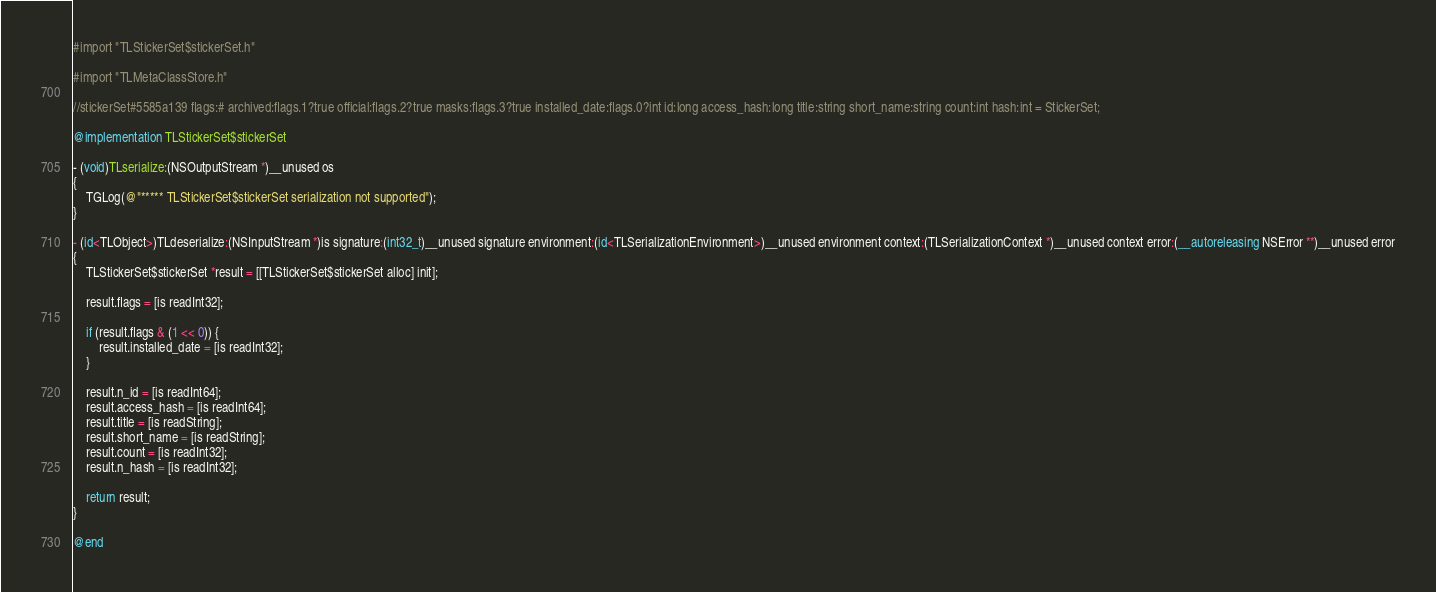<code> <loc_0><loc_0><loc_500><loc_500><_ObjectiveC_>#import "TLStickerSet$stickerSet.h"

#import "TLMetaClassStore.h"

//stickerSet#5585a139 flags:# archived:flags.1?true official:flags.2?true masks:flags.3?true installed_date:flags.0?int id:long access_hash:long title:string short_name:string count:int hash:int = StickerSet;

@implementation TLStickerSet$stickerSet

- (void)TLserialize:(NSOutputStream *)__unused os
{
    TGLog(@"***** TLStickerSet$stickerSet serialization not supported");
}

- (id<TLObject>)TLdeserialize:(NSInputStream *)is signature:(int32_t)__unused signature environment:(id<TLSerializationEnvironment>)__unused environment context:(TLSerializationContext *)__unused context error:(__autoreleasing NSError **)__unused error
{
    TLStickerSet$stickerSet *result = [[TLStickerSet$stickerSet alloc] init];
    
    result.flags = [is readInt32];
    
    if (result.flags & (1 << 0)) {
        result.installed_date = [is readInt32];
    }
    
    result.n_id = [is readInt64];
    result.access_hash = [is readInt64];
    result.title = [is readString];
    result.short_name = [is readString];
    result.count = [is readInt32];
    result.n_hash = [is readInt32];
    
    return result;
}

@end
</code> 